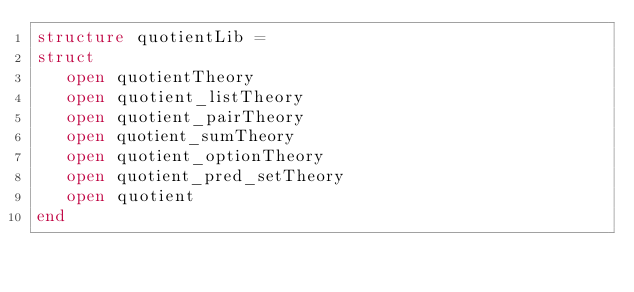<code> <loc_0><loc_0><loc_500><loc_500><_SML_>structure quotientLib =
struct
   open quotientTheory
   open quotient_listTheory
   open quotient_pairTheory
   open quotient_sumTheory
   open quotient_optionTheory
   open quotient_pred_setTheory
   open quotient
end
</code> 